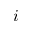<formula> <loc_0><loc_0><loc_500><loc_500>i</formula> 